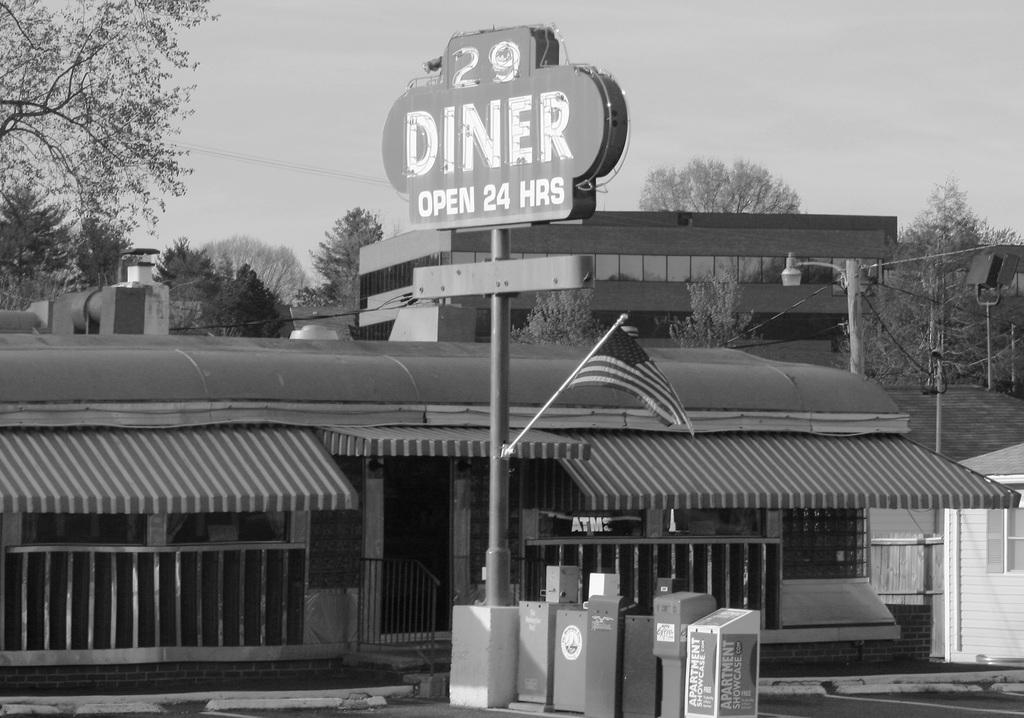Could you give a brief overview of what you see in this image? I see this is a white and black image and I see number of buildings and I see few poles and wires and I see a board over here on which something is written and I see a flag over here and I see few things on which there is something written too. In the background I see the trees and the sky. 